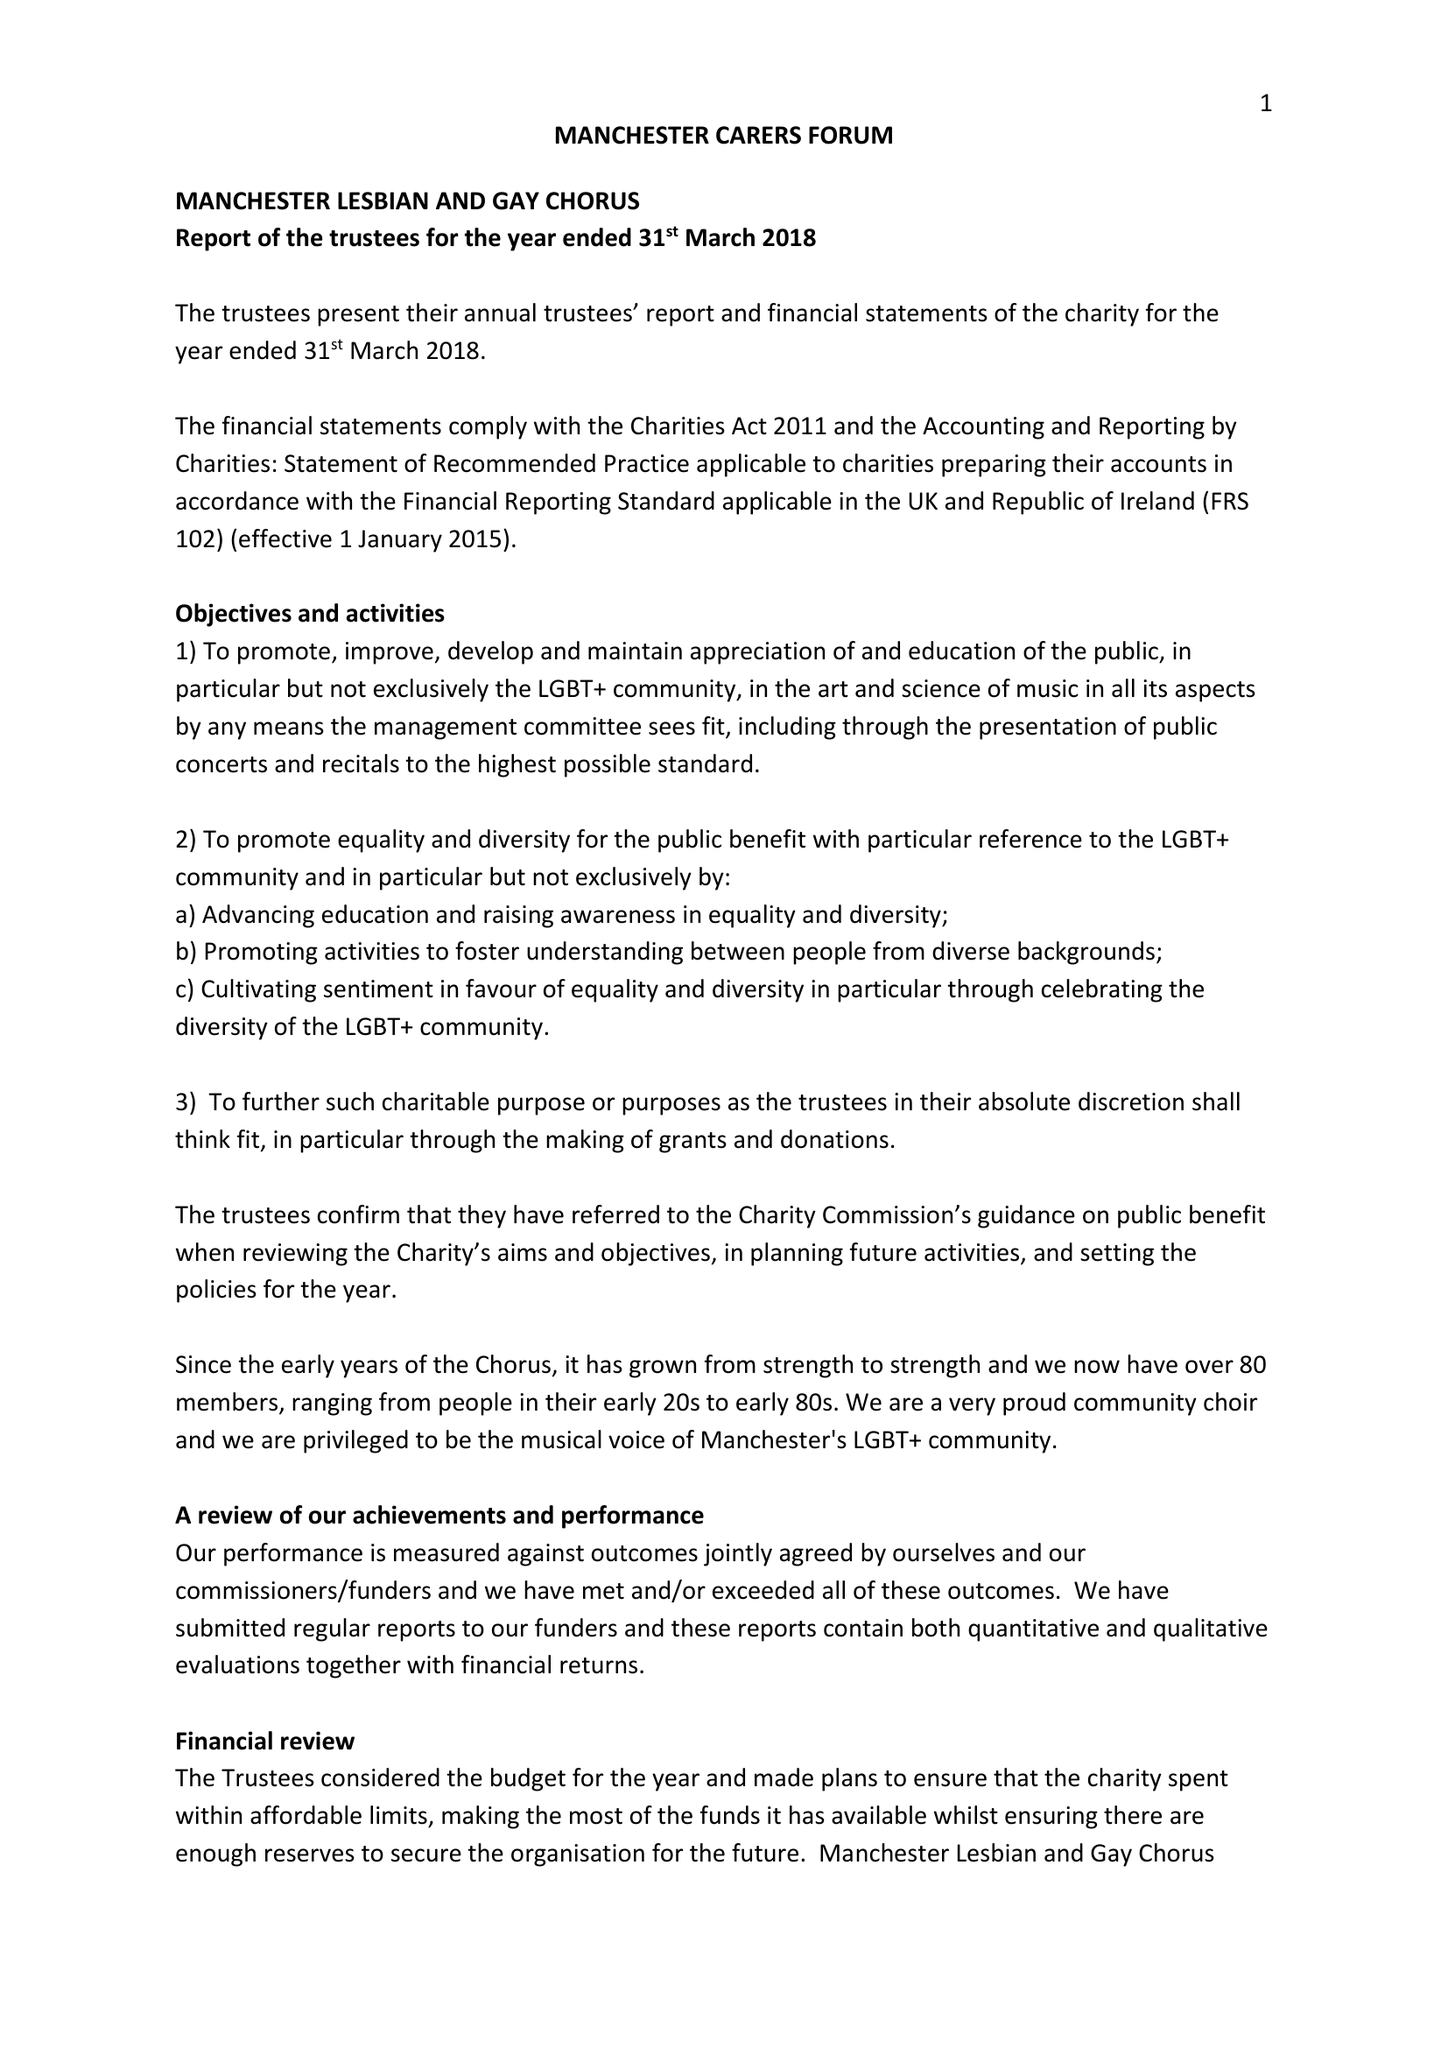What is the value for the address__street_line?
Answer the question using a single word or phrase. 4 HEWITT STREET 